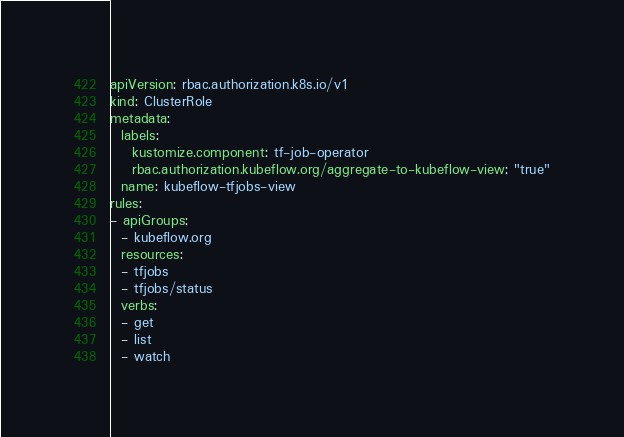Convert code to text. <code><loc_0><loc_0><loc_500><loc_500><_YAML_>apiVersion: rbac.authorization.k8s.io/v1
kind: ClusterRole
metadata:
  labels:
    kustomize.component: tf-job-operator
    rbac.authorization.kubeflow.org/aggregate-to-kubeflow-view: "true"
  name: kubeflow-tfjobs-view
rules:
- apiGroups:
  - kubeflow.org
  resources:
  - tfjobs
  - tfjobs/status
  verbs:
  - get
  - list
  - watch
</code> 